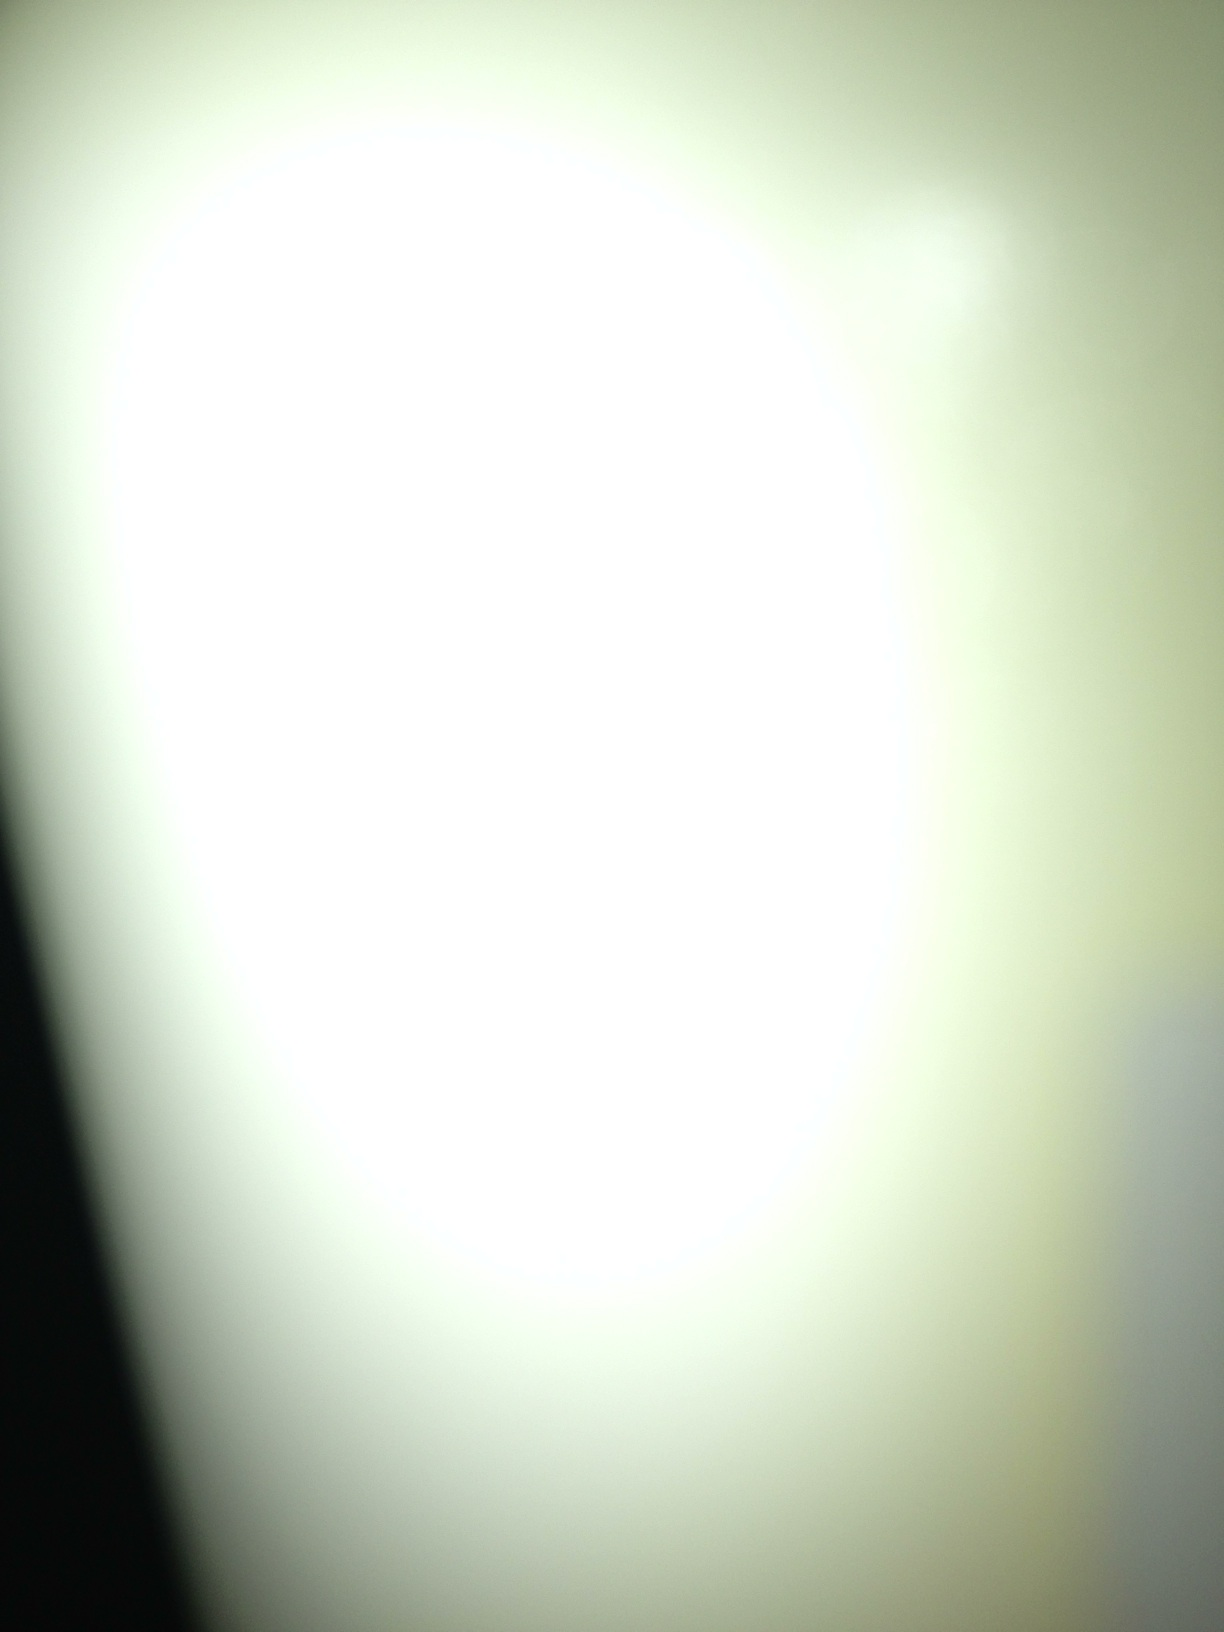What unusual and creative idea does this image spark in you? This image makes me think of an alien communication technique. Imagine that advanced extraterrestrial beings use light patterns to encode complex messages. This particular image could be a snapshot of one such message being transmitted through interstellar space. Deciphering it could unlock knowledge about distant civilizations and their technologies, beliefs, and histories. 